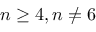Convert formula to latex. <formula><loc_0><loc_0><loc_500><loc_500>n \geq 4 , n \neq 6</formula> 